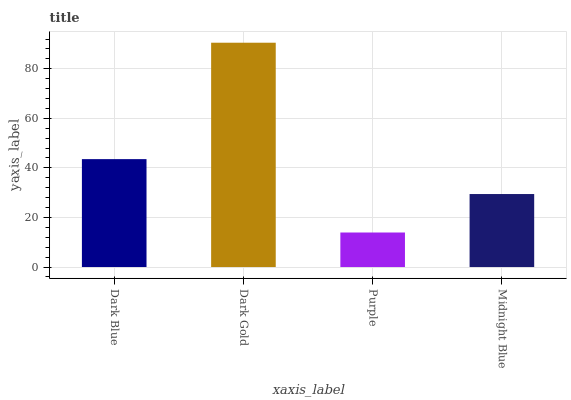Is Purple the minimum?
Answer yes or no. Yes. Is Dark Gold the maximum?
Answer yes or no. Yes. Is Dark Gold the minimum?
Answer yes or no. No. Is Purple the maximum?
Answer yes or no. No. Is Dark Gold greater than Purple?
Answer yes or no. Yes. Is Purple less than Dark Gold?
Answer yes or no. Yes. Is Purple greater than Dark Gold?
Answer yes or no. No. Is Dark Gold less than Purple?
Answer yes or no. No. Is Dark Blue the high median?
Answer yes or no. Yes. Is Midnight Blue the low median?
Answer yes or no. Yes. Is Purple the high median?
Answer yes or no. No. Is Purple the low median?
Answer yes or no. No. 